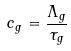<formula> <loc_0><loc_0><loc_500><loc_500>c _ { g } = \frac { \Lambda _ { g } } { \tau _ { g } }</formula> 